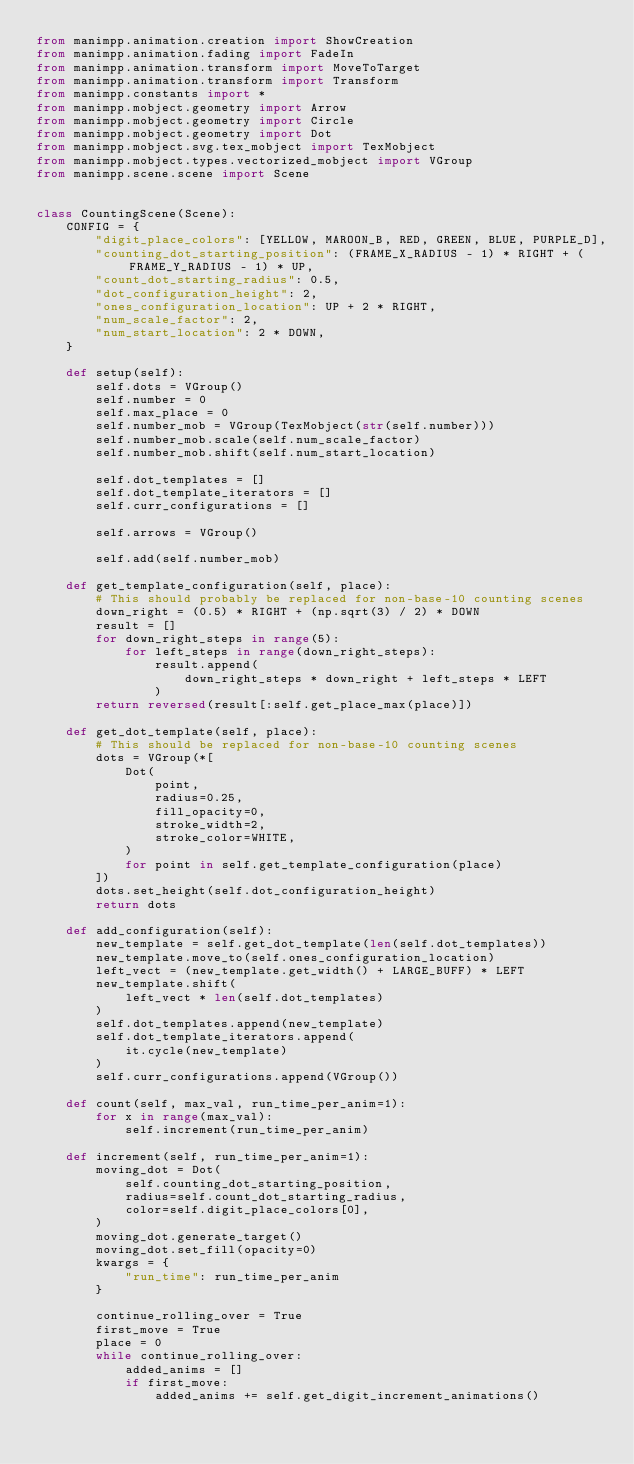Convert code to text. <code><loc_0><loc_0><loc_500><loc_500><_Python_>from manimpp.animation.creation import ShowCreation
from manimpp.animation.fading import FadeIn
from manimpp.animation.transform import MoveToTarget
from manimpp.animation.transform import Transform
from manimpp.constants import *
from manimpp.mobject.geometry import Arrow
from manimpp.mobject.geometry import Circle
from manimpp.mobject.geometry import Dot
from manimpp.mobject.svg.tex_mobject import TexMobject
from manimpp.mobject.types.vectorized_mobject import VGroup
from manimpp.scene.scene import Scene


class CountingScene(Scene):
    CONFIG = {
        "digit_place_colors": [YELLOW, MAROON_B, RED, GREEN, BLUE, PURPLE_D],
        "counting_dot_starting_position": (FRAME_X_RADIUS - 1) * RIGHT + (FRAME_Y_RADIUS - 1) * UP,
        "count_dot_starting_radius": 0.5,
        "dot_configuration_height": 2,
        "ones_configuration_location": UP + 2 * RIGHT,
        "num_scale_factor": 2,
        "num_start_location": 2 * DOWN,
    }

    def setup(self):
        self.dots = VGroup()
        self.number = 0
        self.max_place = 0
        self.number_mob = VGroup(TexMobject(str(self.number)))
        self.number_mob.scale(self.num_scale_factor)
        self.number_mob.shift(self.num_start_location)

        self.dot_templates = []
        self.dot_template_iterators = []
        self.curr_configurations = []

        self.arrows = VGroup()

        self.add(self.number_mob)

    def get_template_configuration(self, place):
        # This should probably be replaced for non-base-10 counting scenes
        down_right = (0.5) * RIGHT + (np.sqrt(3) / 2) * DOWN
        result = []
        for down_right_steps in range(5):
            for left_steps in range(down_right_steps):
                result.append(
                    down_right_steps * down_right + left_steps * LEFT
                )
        return reversed(result[:self.get_place_max(place)])

    def get_dot_template(self, place):
        # This should be replaced for non-base-10 counting scenes
        dots = VGroup(*[
            Dot(
                point,
                radius=0.25,
                fill_opacity=0,
                stroke_width=2,
                stroke_color=WHITE,
            )
            for point in self.get_template_configuration(place)
        ])
        dots.set_height(self.dot_configuration_height)
        return dots

    def add_configuration(self):
        new_template = self.get_dot_template(len(self.dot_templates))
        new_template.move_to(self.ones_configuration_location)
        left_vect = (new_template.get_width() + LARGE_BUFF) * LEFT
        new_template.shift(
            left_vect * len(self.dot_templates)
        )
        self.dot_templates.append(new_template)
        self.dot_template_iterators.append(
            it.cycle(new_template)
        )
        self.curr_configurations.append(VGroup())

    def count(self, max_val, run_time_per_anim=1):
        for x in range(max_val):
            self.increment(run_time_per_anim)

    def increment(self, run_time_per_anim=1):
        moving_dot = Dot(
            self.counting_dot_starting_position,
            radius=self.count_dot_starting_radius,
            color=self.digit_place_colors[0],
        )
        moving_dot.generate_target()
        moving_dot.set_fill(opacity=0)
        kwargs = {
            "run_time": run_time_per_anim
        }

        continue_rolling_over = True
        first_move = True
        place = 0
        while continue_rolling_over:
            added_anims = []
            if first_move:
                added_anims += self.get_digit_increment_animations()</code> 